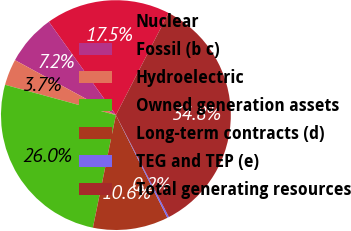Convert chart. <chart><loc_0><loc_0><loc_500><loc_500><pie_chart><fcel>Nuclear<fcel>Fossil (b c)<fcel>Hydroelectric<fcel>Owned generation assets<fcel>Long-term contracts (d)<fcel>TEG and TEP (e)<fcel>Total generating resources<nl><fcel>17.49%<fcel>7.15%<fcel>3.69%<fcel>26.04%<fcel>10.6%<fcel>0.24%<fcel>34.78%<nl></chart> 